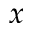<formula> <loc_0><loc_0><loc_500><loc_500>x</formula> 